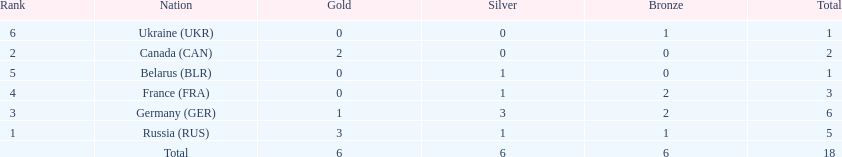Which country won more total medals than tue french, but less than the germans in the 1994 winter olympic biathlon? Russia. Parse the table in full. {'header': ['Rank', 'Nation', 'Gold', 'Silver', 'Bronze', 'Total'], 'rows': [['6', 'Ukraine\xa0(UKR)', '0', '0', '1', '1'], ['2', 'Canada\xa0(CAN)', '2', '0', '0', '2'], ['5', 'Belarus\xa0(BLR)', '0', '1', '0', '1'], ['4', 'France\xa0(FRA)', '0', '1', '2', '3'], ['3', 'Germany\xa0(GER)', '1', '3', '2', '6'], ['1', 'Russia\xa0(RUS)', '3', '1', '1', '5'], ['', 'Total', '6', '6', '6', '18']]} 